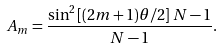<formula> <loc_0><loc_0><loc_500><loc_500>A _ { m } = \frac { \sin ^ { 2 } { [ ( 2 m + 1 ) \theta / 2 ] } \, N - 1 } { N - 1 } .</formula> 